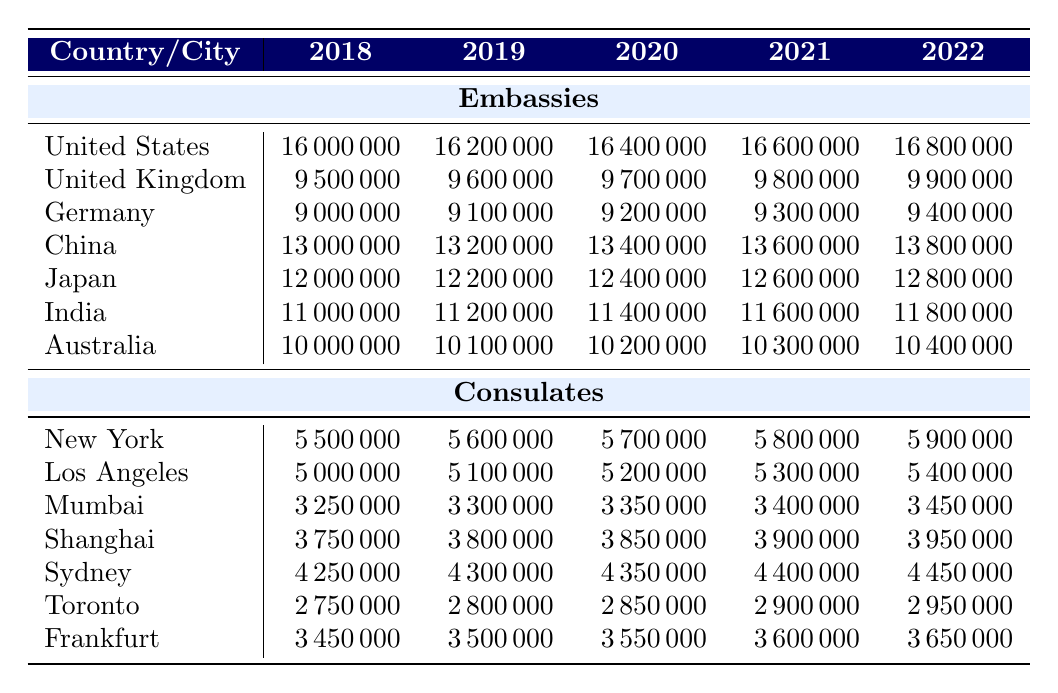What was the expenditure on the United States embassy in 2020? The table shows that the expenditure on the United States embassy in 2020 is listed as 16400000.
Answer: 16400000 In which year did the consulate in Frankurt have the highest expenditure? From the table, we can see that the expenditure for Frankfurt is 3450000 in 2018, 3500000 in 2019, 3550000 in 2020, 3600000 in 2021, and 3650000 in 2022. The highest expenditure occurred in 2022 at 3650000.
Answer: 2022 What is the total expenditure on all embassies in 2019? To find the total for 2019, we sum the expenditures: 16200000 (US) + 9600000 (UK) + 9100000 (Germany) + 13200000 (China) + 12200000 (Japan) + 11200000 (India) + 10100000 (Australia) =  73600000.
Answer: 73600000 Is the expenditure on the consulate in New York higher than in Los Angeles for every year listed from 2018 to 2022? The values for New York are 5500000, 5600000, 5700000, 5800000, 5900000, while the values for Los Angeles are 5000000, 5100000, 5200000, 5300000, 5400000. In each year, New York's expenditure is higher.
Answer: Yes What is the average expenditure for the embassy in Japan over the years 2018 to 2022? The expenditures for Japan from 2018 to 2022 are 12000000, 12200000, 12400000, 12600000, and 12800000. Adding these gives (12000000 + 12200000 + 12400000 + 12600000 + 12800000) / 5 = 12400000.
Answer: 12400000 